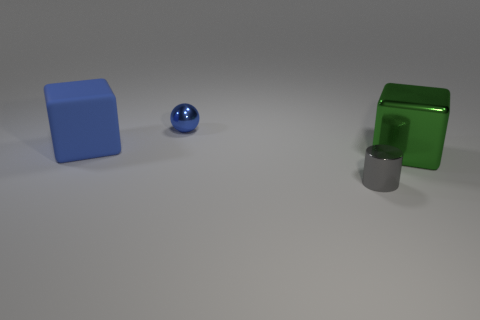Subtract all green cubes. How many cubes are left? 1 Add 4 big metal blocks. How many objects exist? 8 Subtract 0 brown cylinders. How many objects are left? 4 Subtract all cylinders. How many objects are left? 3 Subtract 1 cubes. How many cubes are left? 1 Subtract all red blocks. Subtract all red cylinders. How many blocks are left? 2 Subtract all green balls. How many blue cylinders are left? 0 Subtract all gray cylinders. Subtract all blocks. How many objects are left? 1 Add 4 blue metallic spheres. How many blue metallic spheres are left? 5 Add 4 yellow objects. How many yellow objects exist? 4 